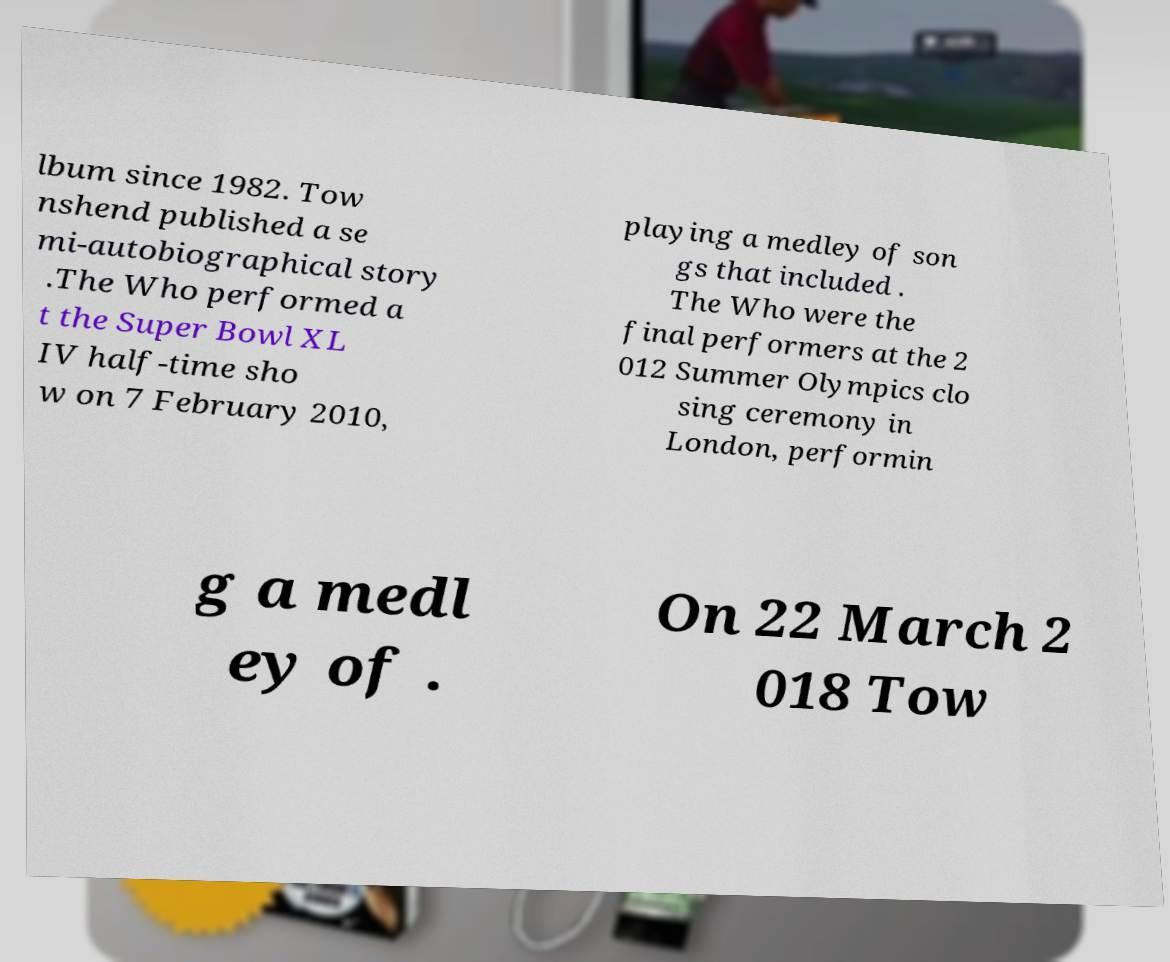There's text embedded in this image that I need extracted. Can you transcribe it verbatim? lbum since 1982. Tow nshend published a se mi-autobiographical story .The Who performed a t the Super Bowl XL IV half-time sho w on 7 February 2010, playing a medley of son gs that included . The Who were the final performers at the 2 012 Summer Olympics clo sing ceremony in London, performin g a medl ey of . On 22 March 2 018 Tow 